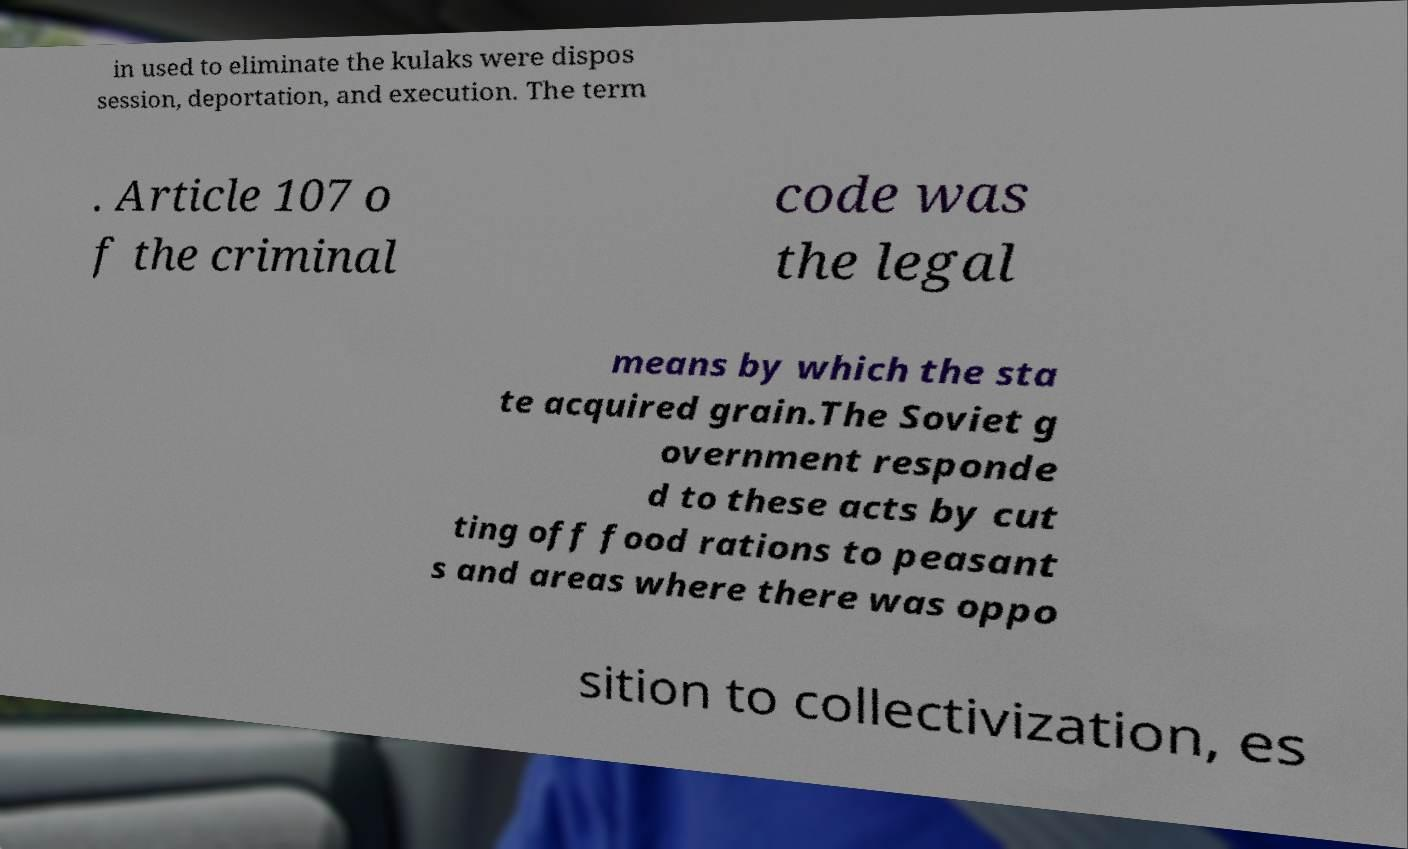Could you extract and type out the text from this image? in used to eliminate the kulaks were dispos session, deportation, and execution. The term . Article 107 o f the criminal code was the legal means by which the sta te acquired grain.The Soviet g overnment responde d to these acts by cut ting off food rations to peasant s and areas where there was oppo sition to collectivization, es 